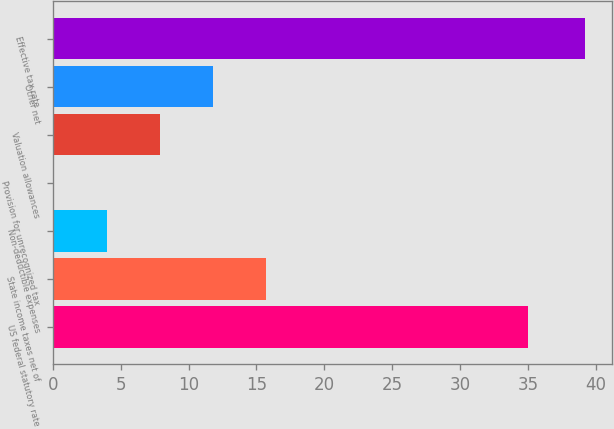Convert chart. <chart><loc_0><loc_0><loc_500><loc_500><bar_chart><fcel>US federal statutory rate<fcel>State income taxes net of<fcel>Non-deductible expenses<fcel>Provision for unrecognized tax<fcel>Valuation allowances<fcel>Other net<fcel>Effective tax rate<nl><fcel>35<fcel>15.74<fcel>4.01<fcel>0.1<fcel>7.92<fcel>11.83<fcel>39.2<nl></chart> 